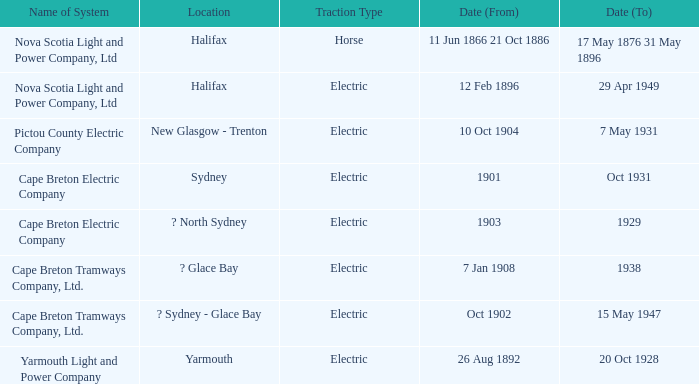What is the date connected to a traction type of electric and the yarmouth light and power company system? 20 Oct 1928. Parse the table in full. {'header': ['Name of System', 'Location', 'Traction Type', 'Date (From)', 'Date (To)'], 'rows': [['Nova Scotia Light and Power Company, Ltd', 'Halifax', 'Horse', '11 Jun 1866 21 Oct 1886', '17 May 1876 31 May 1896'], ['Nova Scotia Light and Power Company, Ltd', 'Halifax', 'Electric', '12 Feb 1896', '29 Apr 1949'], ['Pictou County Electric Company', 'New Glasgow - Trenton', 'Electric', '10 Oct 1904', '7 May 1931'], ['Cape Breton Electric Company', 'Sydney', 'Electric', '1901', 'Oct 1931'], ['Cape Breton Electric Company', '? North Sydney', 'Electric', '1903', '1929'], ['Cape Breton Tramways Company, Ltd.', '? Glace Bay', 'Electric', '7 Jan 1908', '1938'], ['Cape Breton Tramways Company, Ltd.', '? Sydney - Glace Bay', 'Electric', 'Oct 1902', '15 May 1947'], ['Yarmouth Light and Power Company', 'Yarmouth', 'Electric', '26 Aug 1892', '20 Oct 1928']]} 